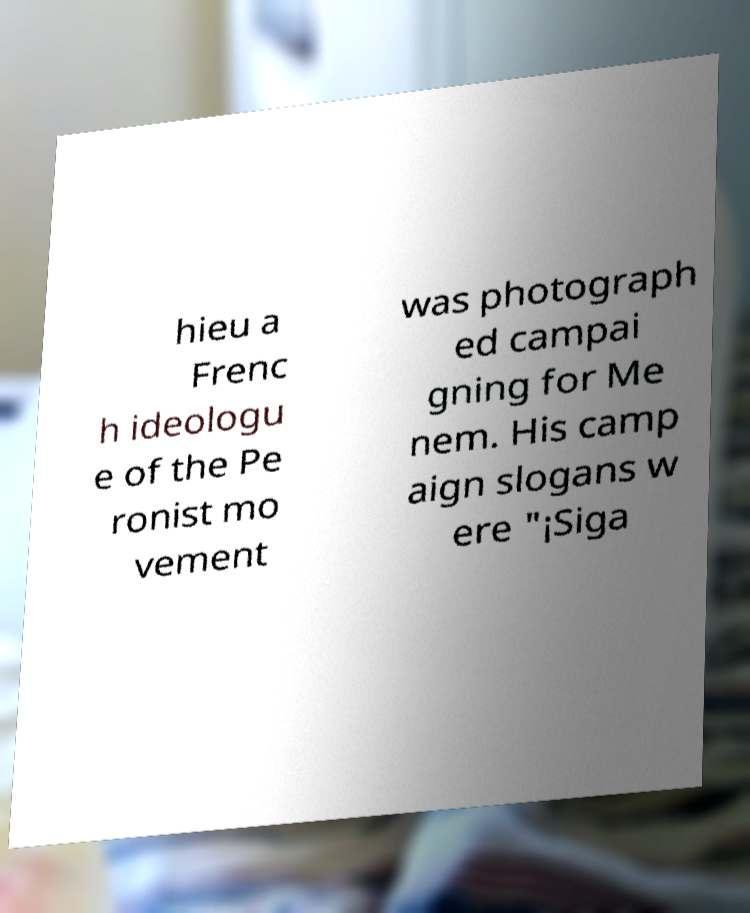For documentation purposes, I need the text within this image transcribed. Could you provide that? hieu a Frenc h ideologu e of the Pe ronist mo vement was photograph ed campai gning for Me nem. His camp aign slogans w ere "¡Siga 